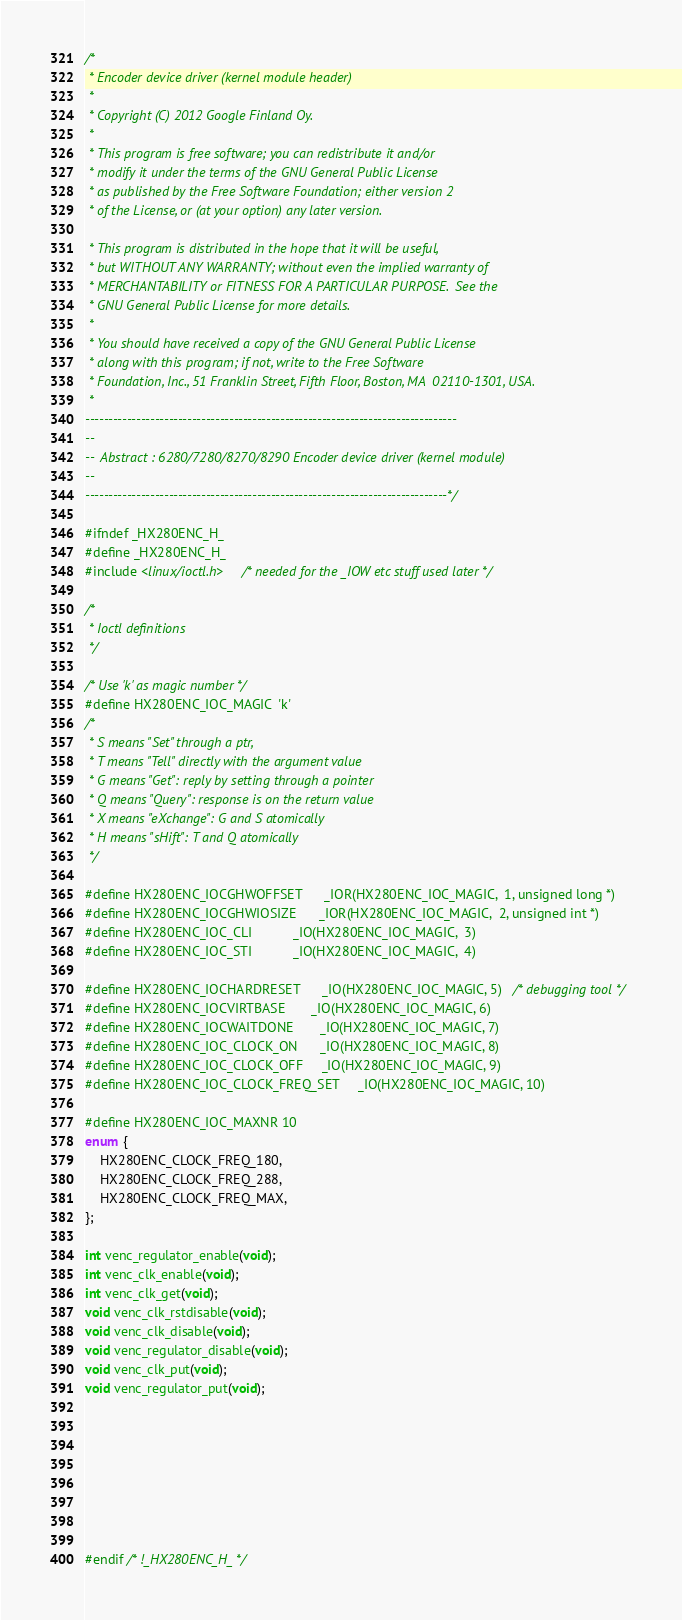<code> <loc_0><loc_0><loc_500><loc_500><_C_>/*
 * Encoder device driver (kernel module header)
 *
 * Copyright (C) 2012 Google Finland Oy.
 *
 * This program is free software; you can redistribute it and/or
 * modify it under the terms of the GNU General Public License
 * as published by the Free Software Foundation; either version 2
 * of the License, or (at your option) any later version.

 * This program is distributed in the hope that it will be useful,
 * but WITHOUT ANY WARRANTY; without even the implied warranty of
 * MERCHANTABILITY or FITNESS FOR A PARTICULAR PURPOSE.  See the
 * GNU General Public License for more details.
 *
 * You should have received a copy of the GNU General Public License
 * along with this program; if not, write to the Free Software
 * Foundation, Inc., 51 Franklin Street, Fifth Floor, Boston, MA  02110-1301, USA.
 *
--------------------------------------------------------------------------------
--
--  Abstract : 6280/7280/8270/8290 Encoder device driver (kernel module)
--
------------------------------------------------------------------------------*/

#ifndef _HX280ENC_H_
#define _HX280ENC_H_
#include <linux/ioctl.h>    /* needed for the _IOW etc stuff used later */

/*
 * Ioctl definitions
 */

/* Use 'k' as magic number */
#define HX280ENC_IOC_MAGIC  'k'
/*
 * S means "Set" through a ptr,
 * T means "Tell" directly with the argument value
 * G means "Get": reply by setting through a pointer
 * Q means "Query": response is on the return value
 * X means "eXchange": G and S atomically
 * H means "sHift": T and Q atomically
 */

#define HX280ENC_IOCGHWOFFSET      _IOR(HX280ENC_IOC_MAGIC,  1, unsigned long *)
#define HX280ENC_IOCGHWIOSIZE      _IOR(HX280ENC_IOC_MAGIC,  2, unsigned int *)
#define HX280ENC_IOC_CLI           _IO(HX280ENC_IOC_MAGIC,  3)
#define HX280ENC_IOC_STI           _IO(HX280ENC_IOC_MAGIC,  4)

#define HX280ENC_IOCHARDRESET      _IO(HX280ENC_IOC_MAGIC, 5)   /* debugging tool */
#define HX280ENC_IOCVIRTBASE       _IO(HX280ENC_IOC_MAGIC, 6)
#define HX280ENC_IOCWAITDONE       _IO(HX280ENC_IOC_MAGIC, 7)
#define HX280ENC_IOC_CLOCK_ON      _IO(HX280ENC_IOC_MAGIC, 8)
#define HX280ENC_IOC_CLOCK_OFF     _IO(HX280ENC_IOC_MAGIC, 9)
#define HX280ENC_IOC_CLOCK_FREQ_SET     _IO(HX280ENC_IOC_MAGIC, 10)

#define HX280ENC_IOC_MAXNR 10
enum {
    HX280ENC_CLOCK_FREQ_180,
    HX280ENC_CLOCK_FREQ_288,
    HX280ENC_CLOCK_FREQ_MAX,
};

int venc_regulator_enable(void);
int venc_clk_enable(void);
int venc_clk_get(void);
void venc_clk_rstdisable(void);
void venc_clk_disable(void);
void venc_regulator_disable(void);
void venc_clk_put(void);
void venc_regulator_put(void);








#endif /* !_HX280ENC_H_ */
</code> 